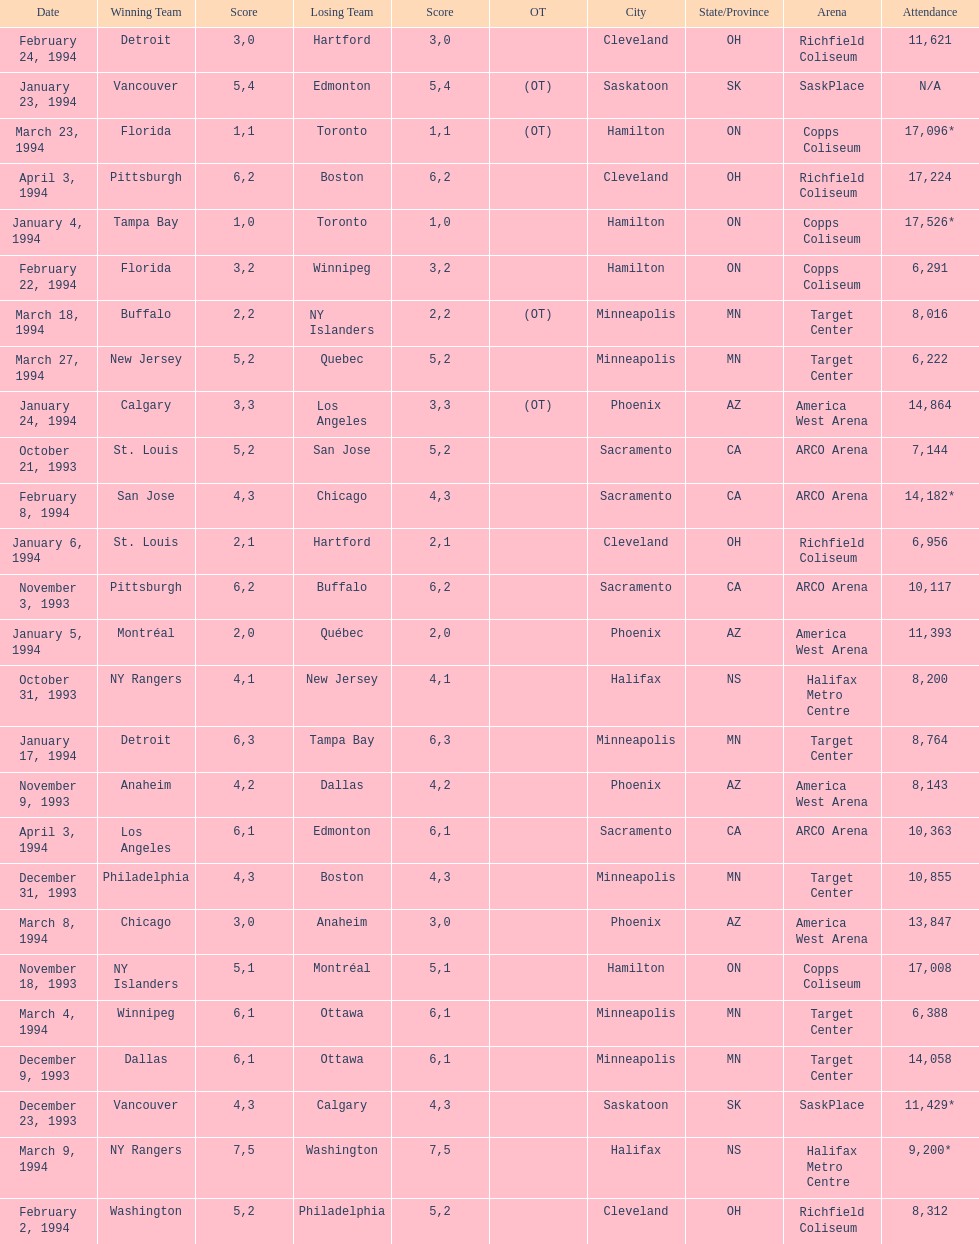What is the difference in attendance between the november 18, 1993 games and the november 9th game? 8865. 